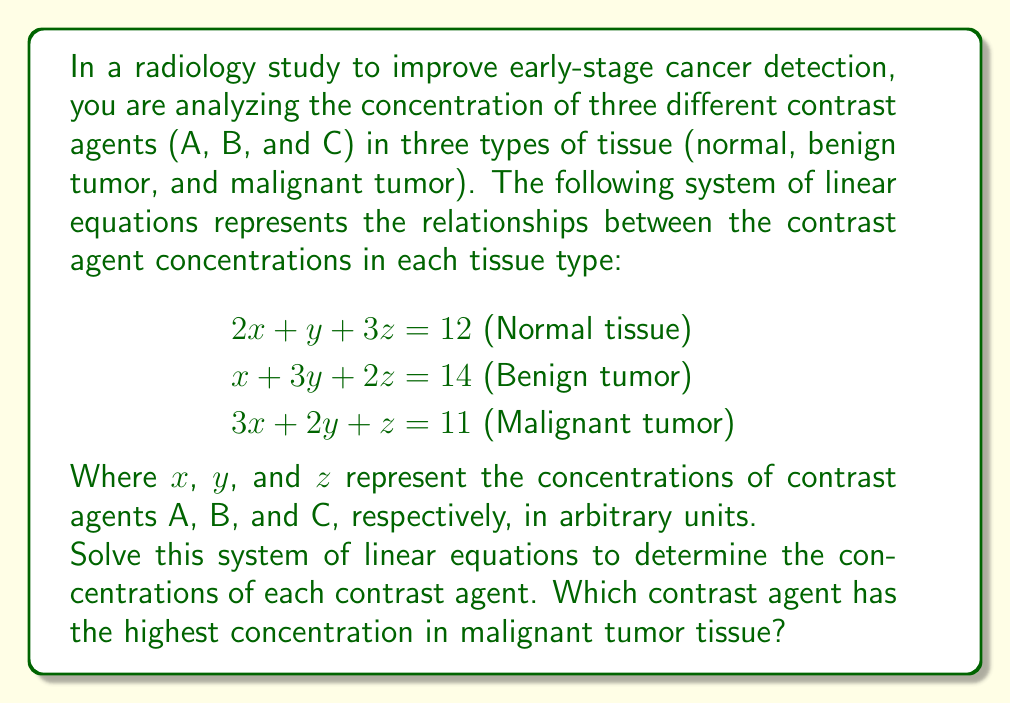Solve this math problem. To solve this system of linear equations, we'll use the Gaussian elimination method:

1) First, write the augmented matrix:

$$\begin{bmatrix}
2 & 1 & 3 & 12 \\
1 & 3 & 2 & 14 \\
3 & 2 & 1 & 11
\end{bmatrix}$$

2) Multiply the first row by -1/2 and add it to the second row:

$$\begin{bmatrix}
2 & 1 & 3 & 12 \\
0 & 5/2 & 1/2 & 8 \\
3 & 2 & 1 & 11
\end{bmatrix}$$

3) Multiply the first row by -3/2 and add it to the third row:

$$\begin{bmatrix}
2 & 1 & 3 & 12 \\
0 & 5/2 & 1/2 & 8 \\
0 & 1/2 & -7/2 & -7
\end{bmatrix}$$

4) Multiply the second row by -1/5 and add it to the third row:

$$\begin{bmatrix}
2 & 1 & 3 & 12 \\
0 & 5/2 & 1/2 & 8 \\
0 & 0 & -15/4 & -39/5
\end{bmatrix}$$

5) Now we have an upper triangular matrix. We can solve for $z$:

$-\frac{15}{4}z = -\frac{39}{5}$
$z = \frac{52}{25} = 2.08$

6) Substitute this value in the second equation:

$\frac{5}{2}y + \frac{1}{2}(2.08) = 8$
$\frac{5}{2}y = 6.96$
$y = 2.784$

7) Finally, substitute these values in the first equation:

$2x + 2.784 + 3(2.08) = 12$
$2x = 12 - 2.784 - 6.24 = 2.976$
$x = 1.488$

Therefore, the concentrations are:
$x = 1.488$ (Contrast agent A)
$y = 2.784$ (Contrast agent B)
$z = 2.08$ (Contrast agent C)

To determine which contrast agent has the highest concentration in malignant tumor tissue, we need to look at the coefficients in the third equation:

$3x + 2y + z = 11$

Substituting the values:

$3(1.488) + 2(2.784) + 2.08 = 11$

The largest term is $2(2.784) = 5.568$, which corresponds to contrast agent B.
Answer: The concentrations of contrast agents are:
A: $x = 1.488$
B: $y = 2.784$
C: $z = 2.08$

Contrast agent B has the highest concentration in malignant tumor tissue. 